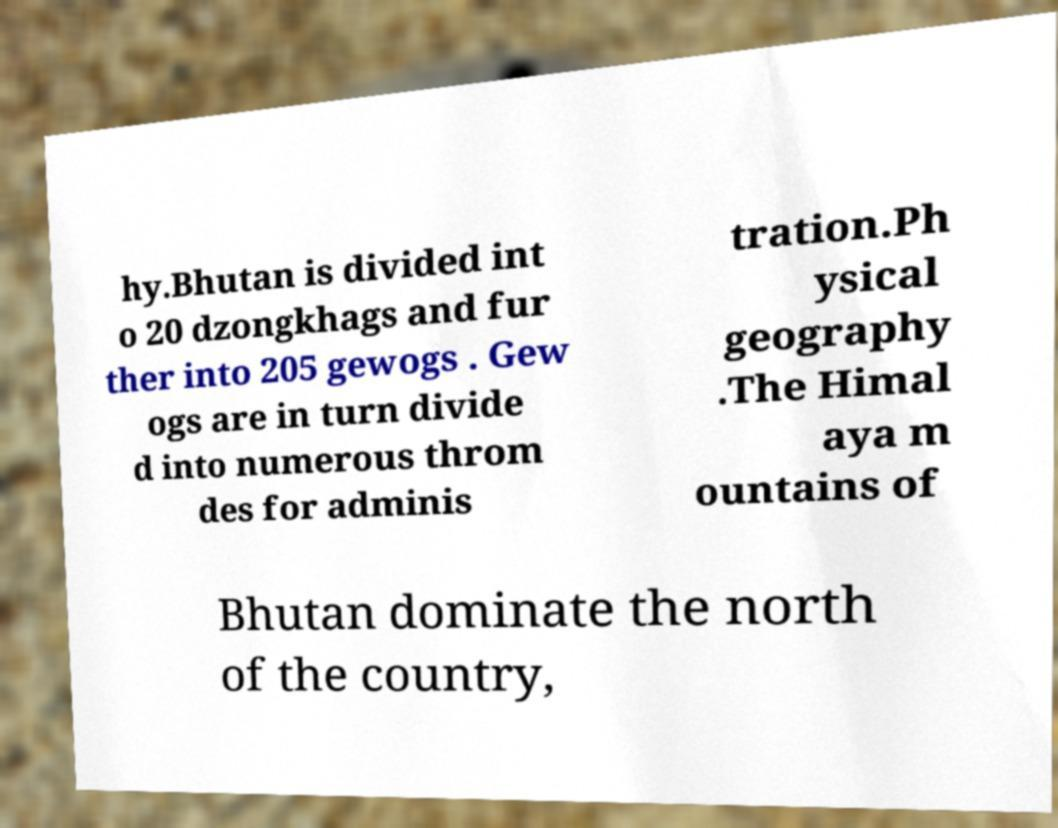Could you extract and type out the text from this image? hy.Bhutan is divided int o 20 dzongkhags and fur ther into 205 gewogs . Gew ogs are in turn divide d into numerous throm des for adminis tration.Ph ysical geography .The Himal aya m ountains of Bhutan dominate the north of the country, 